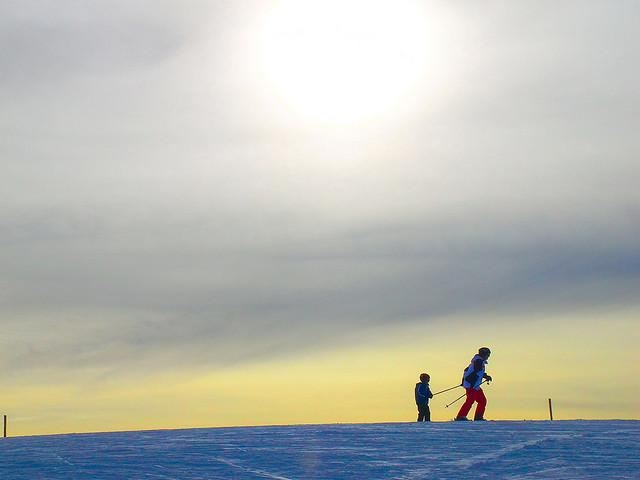What is the father doing with the child out on the mountain? Please explain your reasoning. teaching. Pulling his child. 